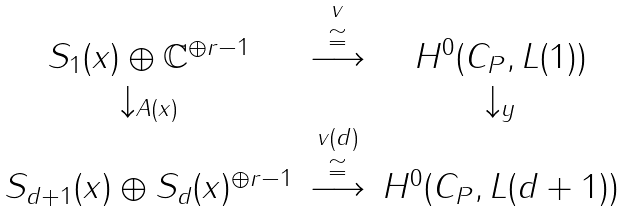<formula> <loc_0><loc_0><loc_500><loc_500>\begin{matrix} S _ { 1 } ( x ) \oplus \mathbb { C } ^ { \oplus r - 1 } & \overset { v } { \stackrel { \cong } { \longrightarrow } } & H ^ { 0 } ( C _ { P } , L ( 1 ) ) \\ \downarrow _ { A ( x ) } & & \downarrow _ { y } \\ S _ { d + 1 } ( x ) \oplus S _ { d } ( x ) ^ { \oplus r - 1 } & \overset { v ( d ) } { \stackrel { \cong } { \longrightarrow } } & H ^ { 0 } ( C _ { P } , L ( d + 1 ) ) \end{matrix}</formula> 